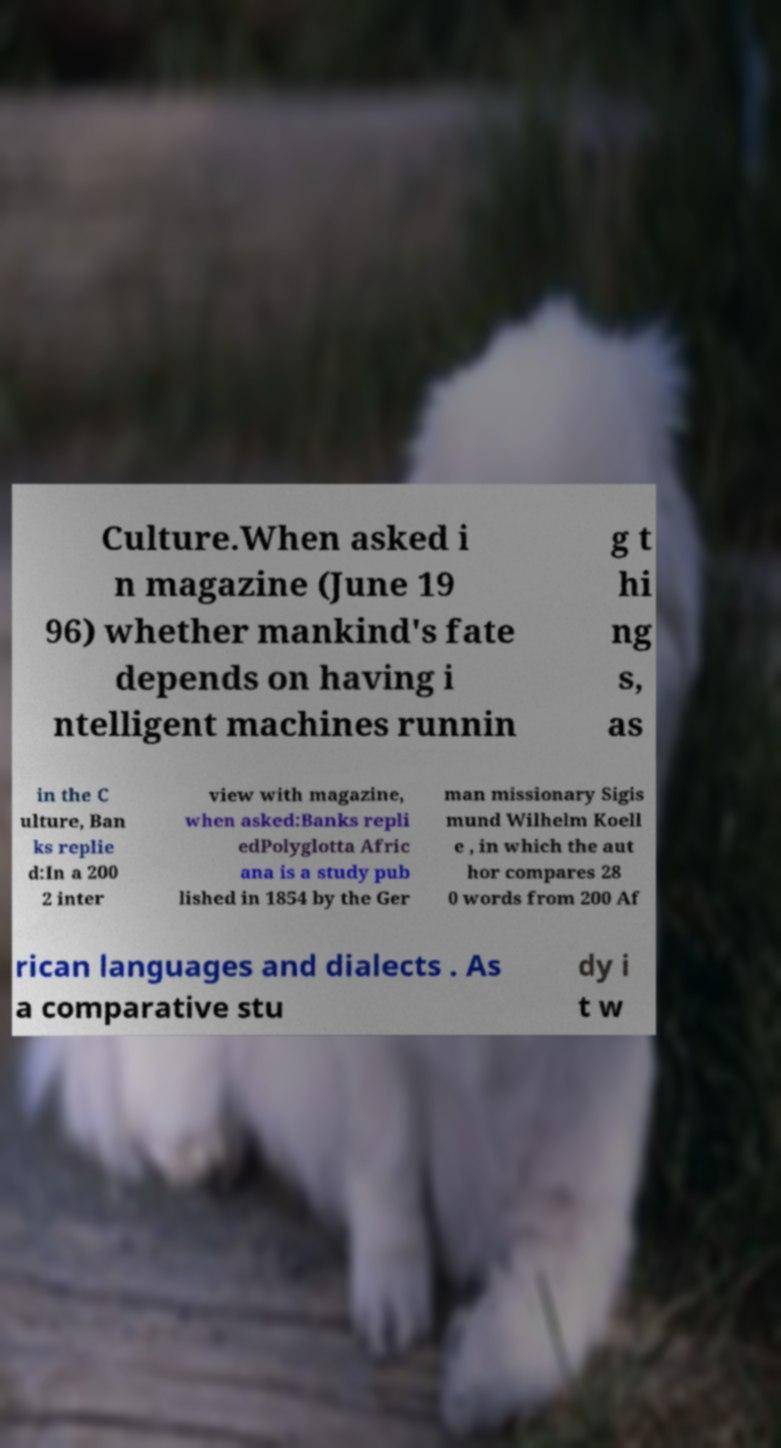Please identify and transcribe the text found in this image. Culture.When asked i n magazine (June 19 96) whether mankind's fate depends on having i ntelligent machines runnin g t hi ng s, as in the C ulture, Ban ks replie d:In a 200 2 inter view with magazine, when asked:Banks repli edPolyglotta Afric ana is a study pub lished in 1854 by the Ger man missionary Sigis mund Wilhelm Koell e , in which the aut hor compares 28 0 words from 200 Af rican languages and dialects . As a comparative stu dy i t w 